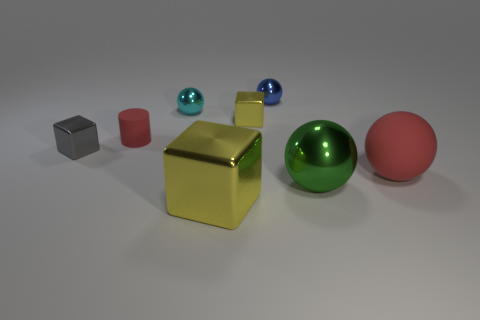Add 1 tiny red cylinders. How many objects exist? 9 Subtract all cubes. How many objects are left? 5 Subtract all small red blocks. Subtract all yellow metallic cubes. How many objects are left? 6 Add 7 blue spheres. How many blue spheres are left? 8 Add 1 shiny balls. How many shiny balls exist? 4 Subtract 0 red cubes. How many objects are left? 8 